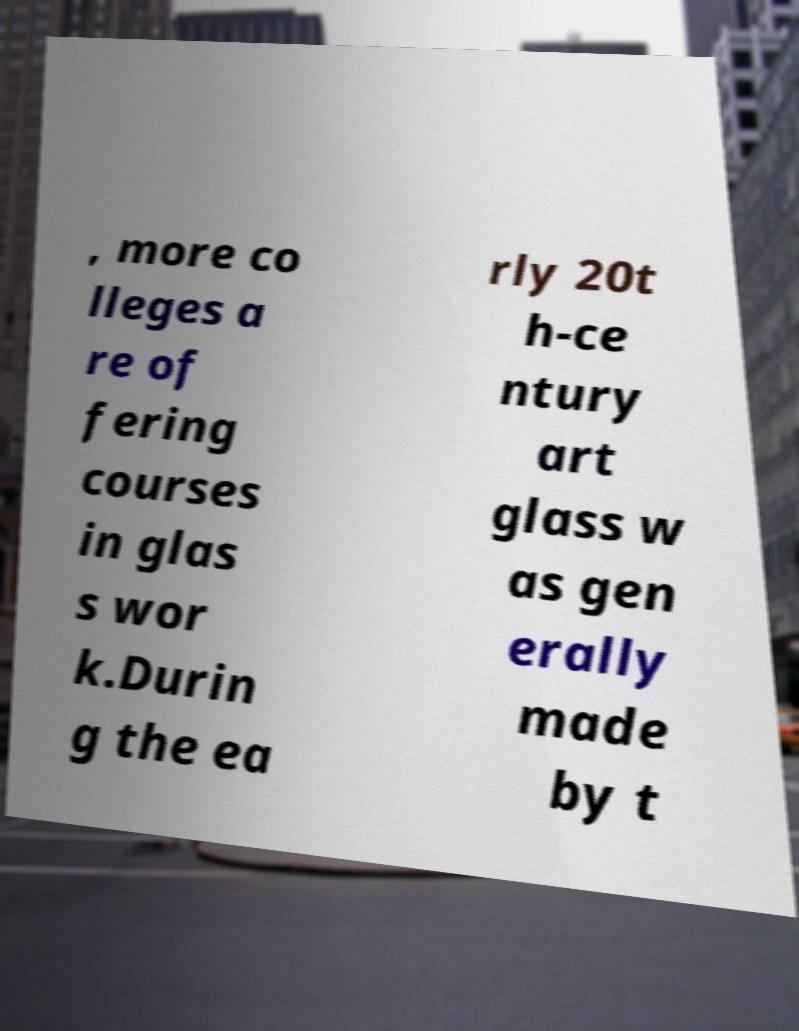For documentation purposes, I need the text within this image transcribed. Could you provide that? , more co lleges a re of fering courses in glas s wor k.Durin g the ea rly 20t h-ce ntury art glass w as gen erally made by t 